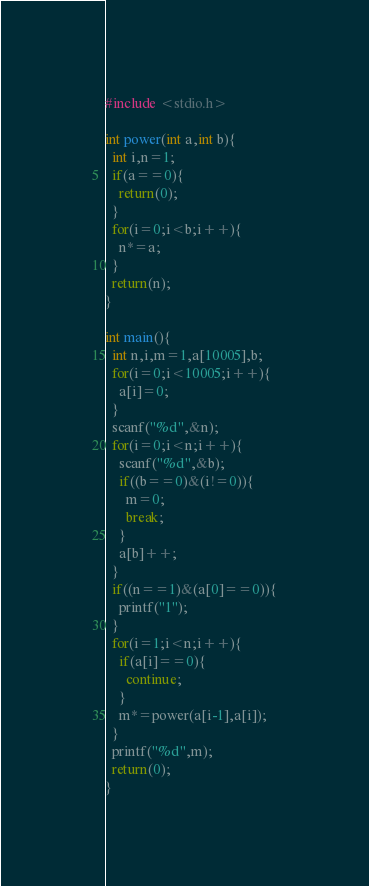<code> <loc_0><loc_0><loc_500><loc_500><_C_>#include <stdio.h>

int power(int a,int b){
  int i,n=1;
  if(a==0){
    return(0);
  }
  for(i=0;i<b;i++){
    n*=a;
  }
  return(n);
}

int main(){
  int n,i,m=1,a[10005],b;
  for(i=0;i<10005;i++){
    a[i]=0;
  }
  scanf("%d",&n);
  for(i=0;i<n;i++){
    scanf("%d",&b);
    if((b==0)&(i!=0)){
      m=0;
      break;
    }
    a[b]++;
  }
  if((n==1)&(a[0]==0)){
    printf("1");
  }
  for(i=1;i<n;i++){
    if(a[i]==0){
      continue;
    }
    m*=power(a[i-1],a[i]);
  }
  printf("%d",m);
  return(0);
}</code> 